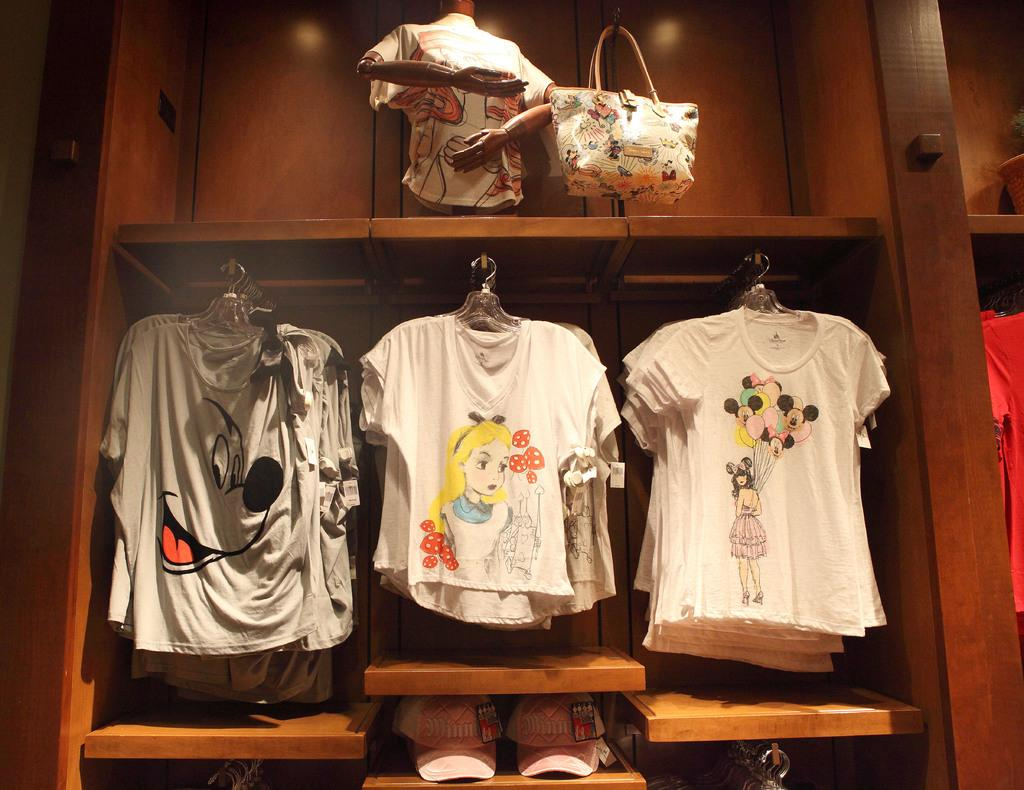Where was the image taken? The image was taken in a room. What can be seen hanging on the shelf in the image? There are clothes hanging on a shelf in the image. What material is the shelf made of? The shelf is made of wood. What direction is the advertisement pointing in the image? There is no advertisement present in the image. 